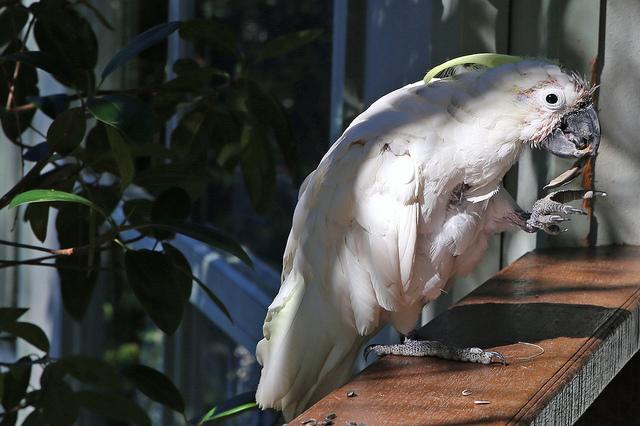What is the bird standing on?
Be succinct. Railing. Is the bird standing on both feet?
Quick response, please. No. Is the parrot flying?
Concise answer only. No. 